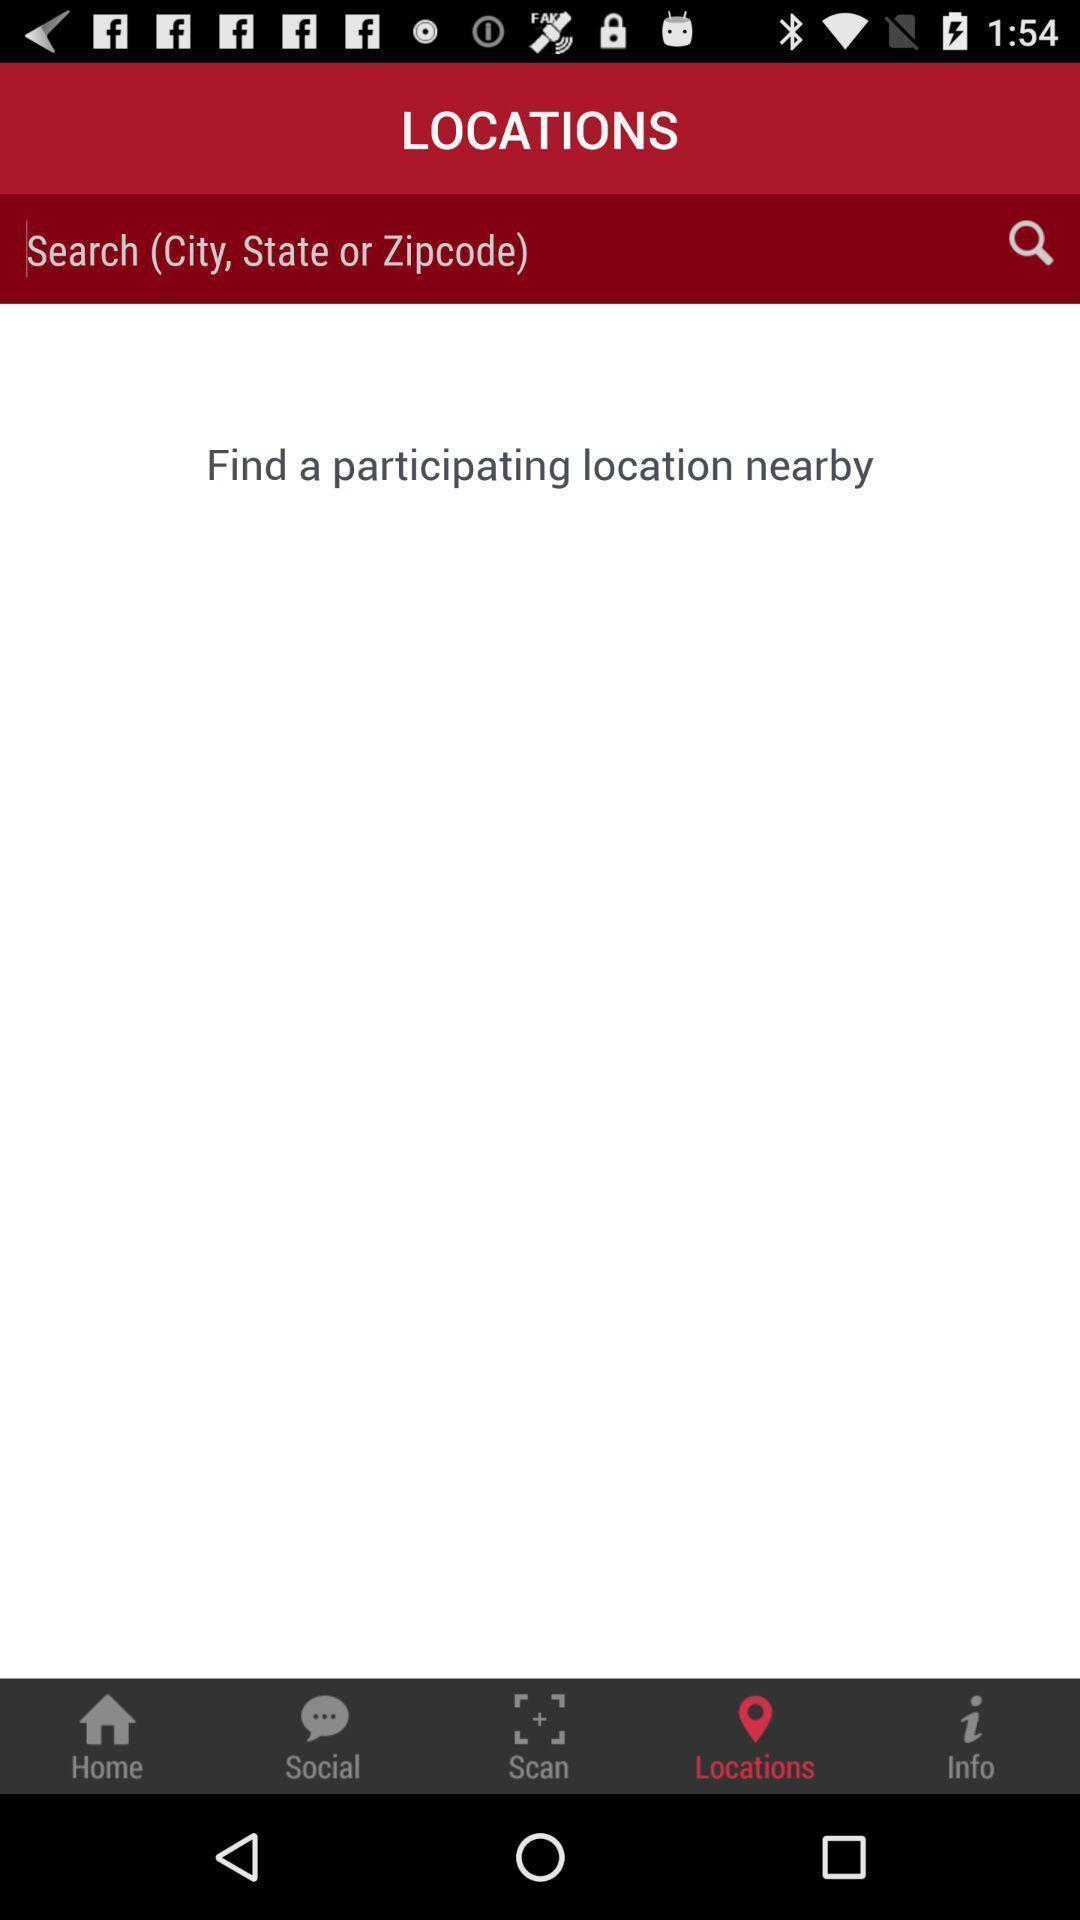Describe the key features of this screenshot. Screen shows search city option. 